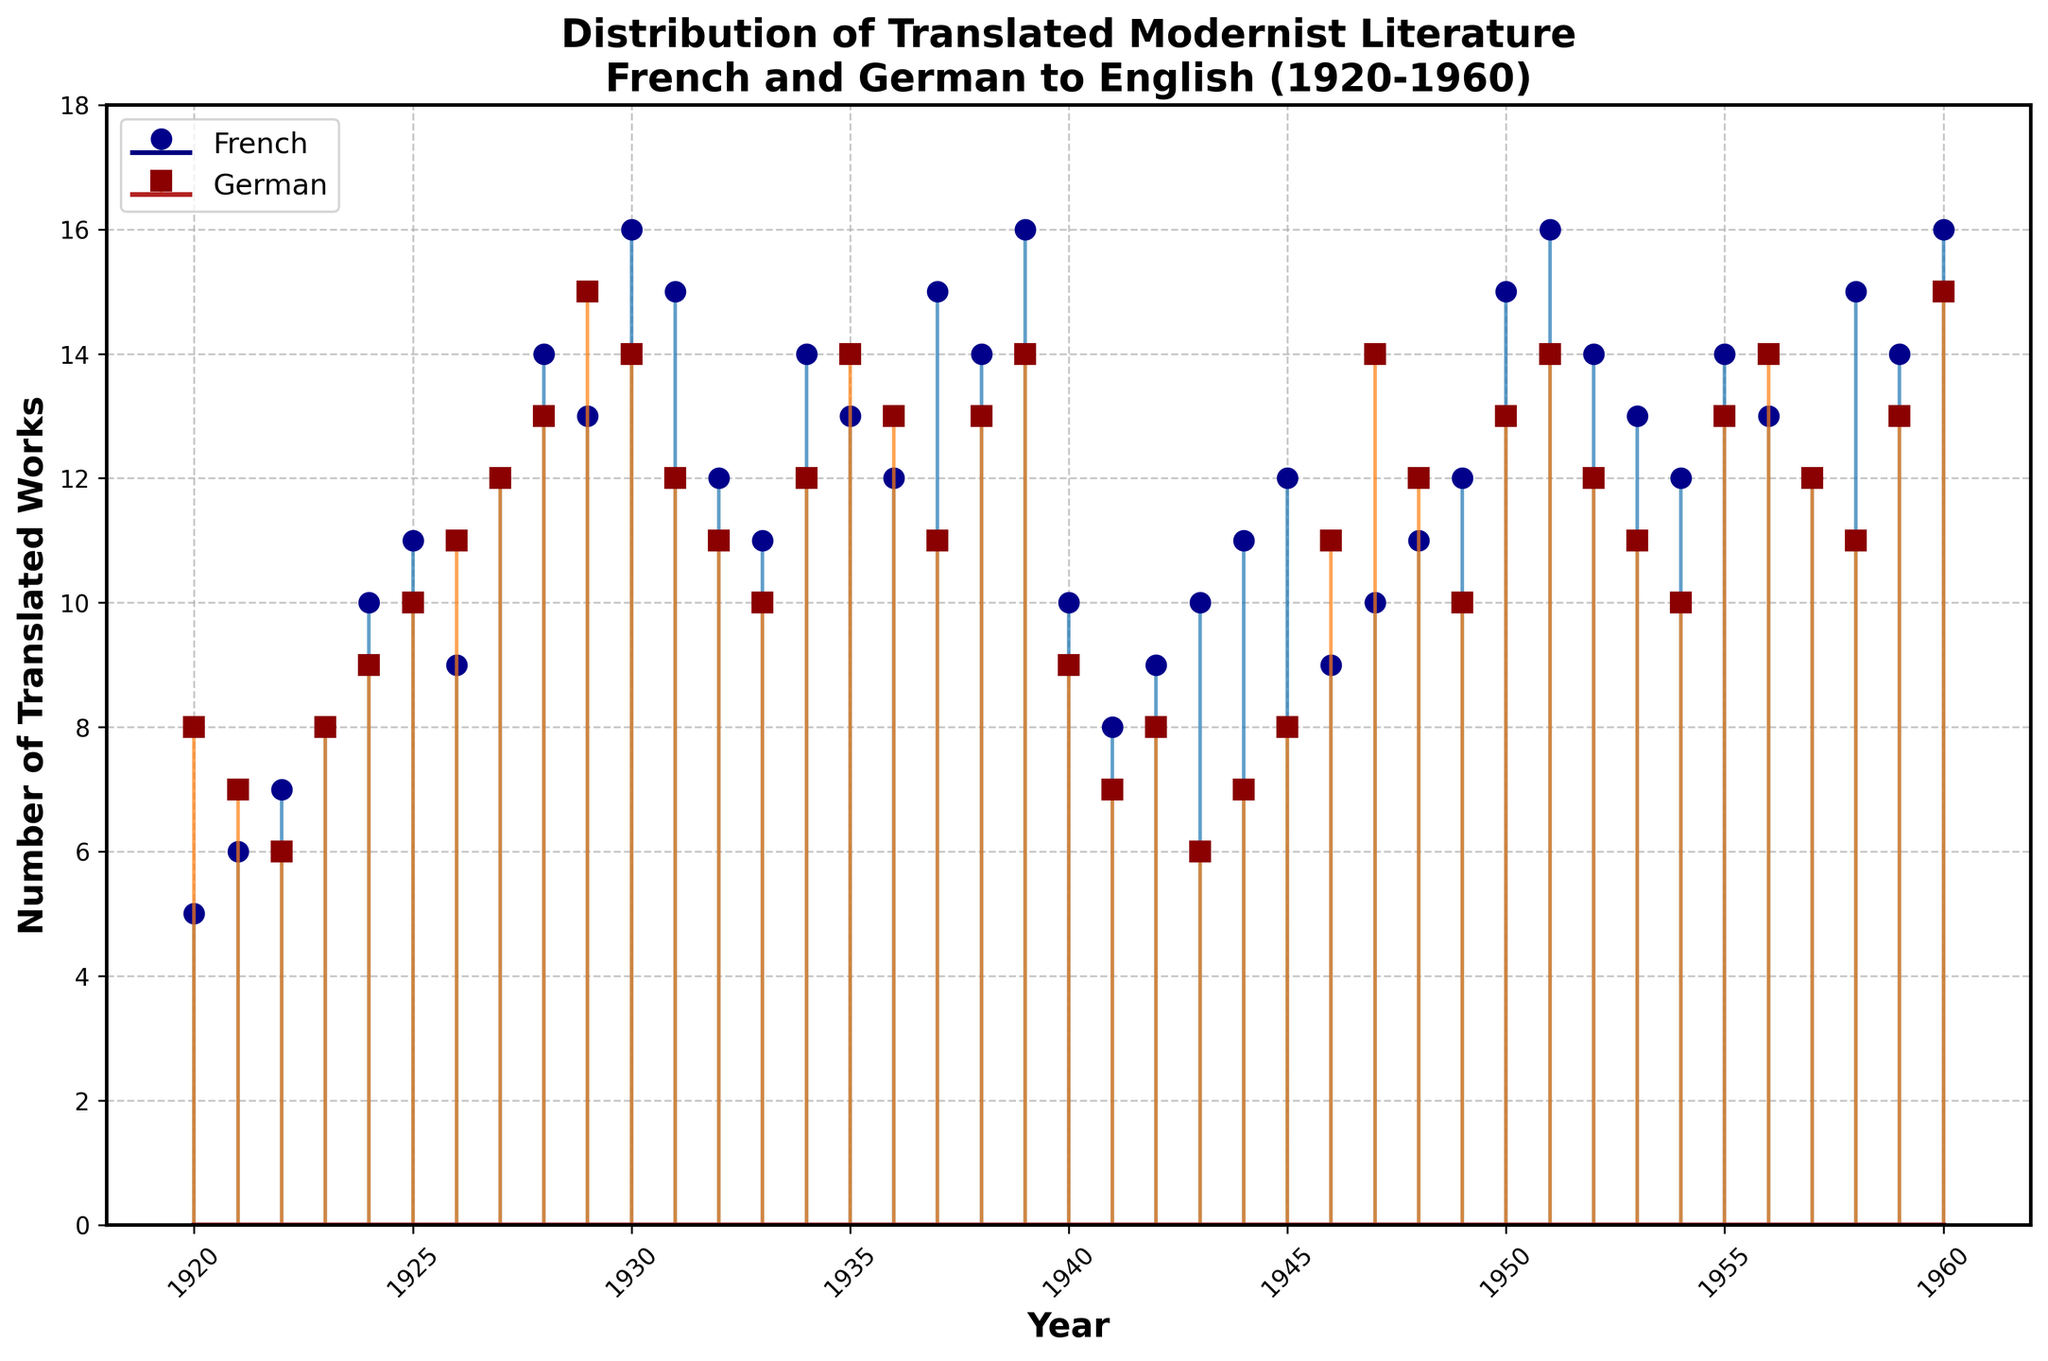What is the title of the stem plot? The title is written at the top of the stem plot, providing an overview of what the figure represents.
Answer: Distribution of Translated Modernist Literature French and German to English (1920-1960) How is the x-axis labeled? The x-axis label is displayed horizontally below the plot, showing the context of the data points along this axis.
Answer: Year How many translated French works are there in 1930? Find the data point corresponding to the year 1930 on the x-axis and follow it vertically to the stem and marker representing the French works.
Answer: 16 When did the number of translated German works peak? Look for the highest data point on the stem plot for the German works, which are represented by the dark red markers.
Answer: 1960 What is the difference in the number of translated French works between 1925 and 1955? Identify the number of translated works for French in both 1925 and 1955, and then calculate the difference: 11 (1925) - 14 (1955) = -3
Answer: -3 Which year saw an equal number of translated French and German works? Find the year(s) where the heights of the stems for French and German works match.
Answer: 1923 Between the years 1940 and 1945, how did the trend of translated German works change? Analyze the data points from 1940 to 1945 for German works, noting the rise or fall in the number of translations.
Answer: Decreased then increased What was the average number of translated German works from 1920 to 1925? Sum the number of translated German works for each year from 1920 to 1925 and divide by the number of years (6): (8 + 7 + 6 + 8 + 9 + 10) / 6 = 48 / 6.
Answer: 8 In which decade did French works see the most significant increase in translations? Compare the data points over each decade, identifying the decade with the greatest increase from start to end.
Answer: 1920s Compare the number of translated French works in 1937 and 1957. Which year had more translations and by how much? Identify the number of translated French works in 1937 and 1957 and then subtract 1937's value from 1957's value: 12 (1957) - 15 (1937) = -3.
Answer: 1937, by 3 